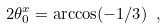<formula> <loc_0><loc_0><loc_500><loc_500>2 \theta _ { 0 } ^ { x } = \arccos ( - 1 / 3 ) \ ,</formula> 